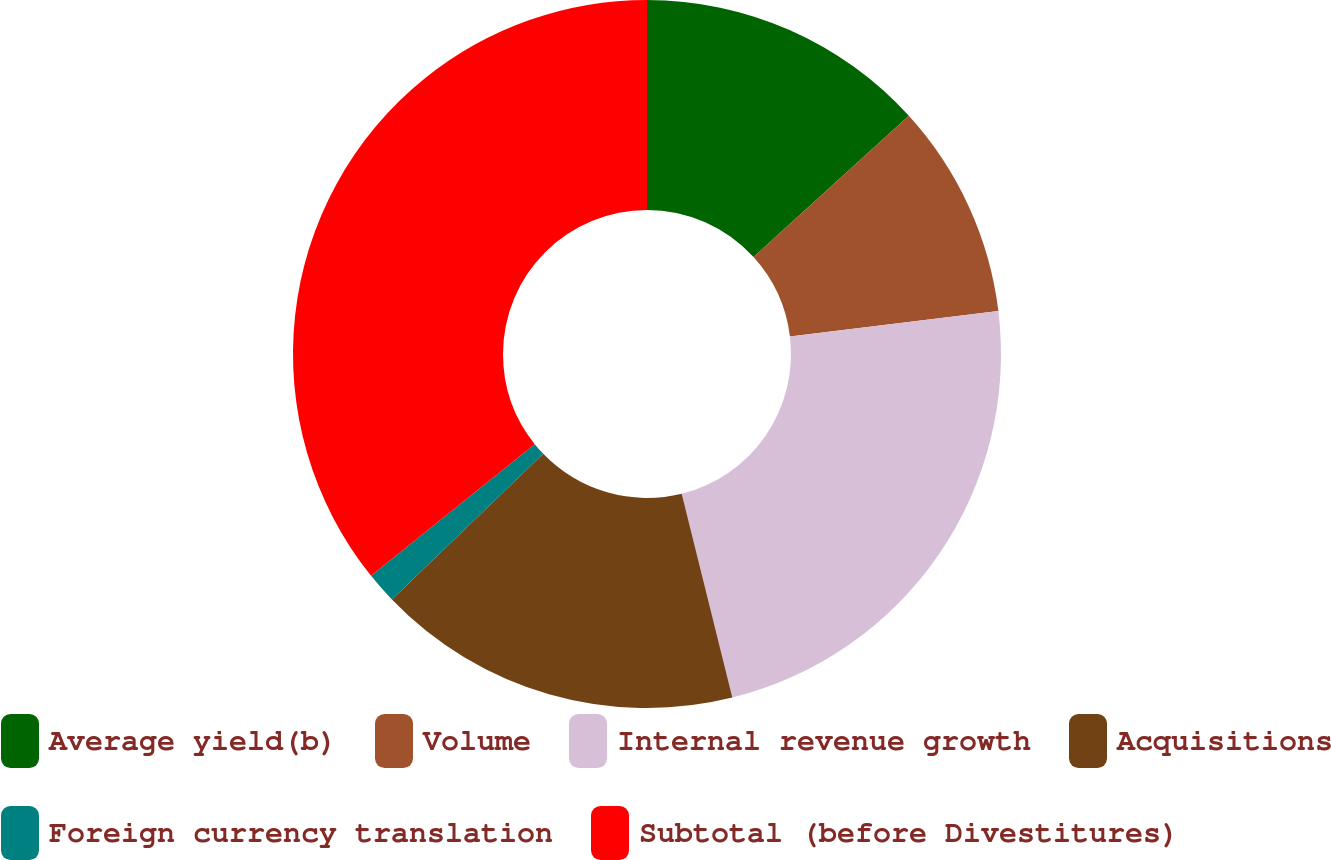Convert chart. <chart><loc_0><loc_0><loc_500><loc_500><pie_chart><fcel>Average yield(b)<fcel>Volume<fcel>Internal revenue growth<fcel>Acquisitions<fcel>Foreign currency translation<fcel>Subtotal (before Divestitures)<nl><fcel>13.25%<fcel>9.81%<fcel>23.06%<fcel>16.68%<fcel>1.42%<fcel>35.77%<nl></chart> 